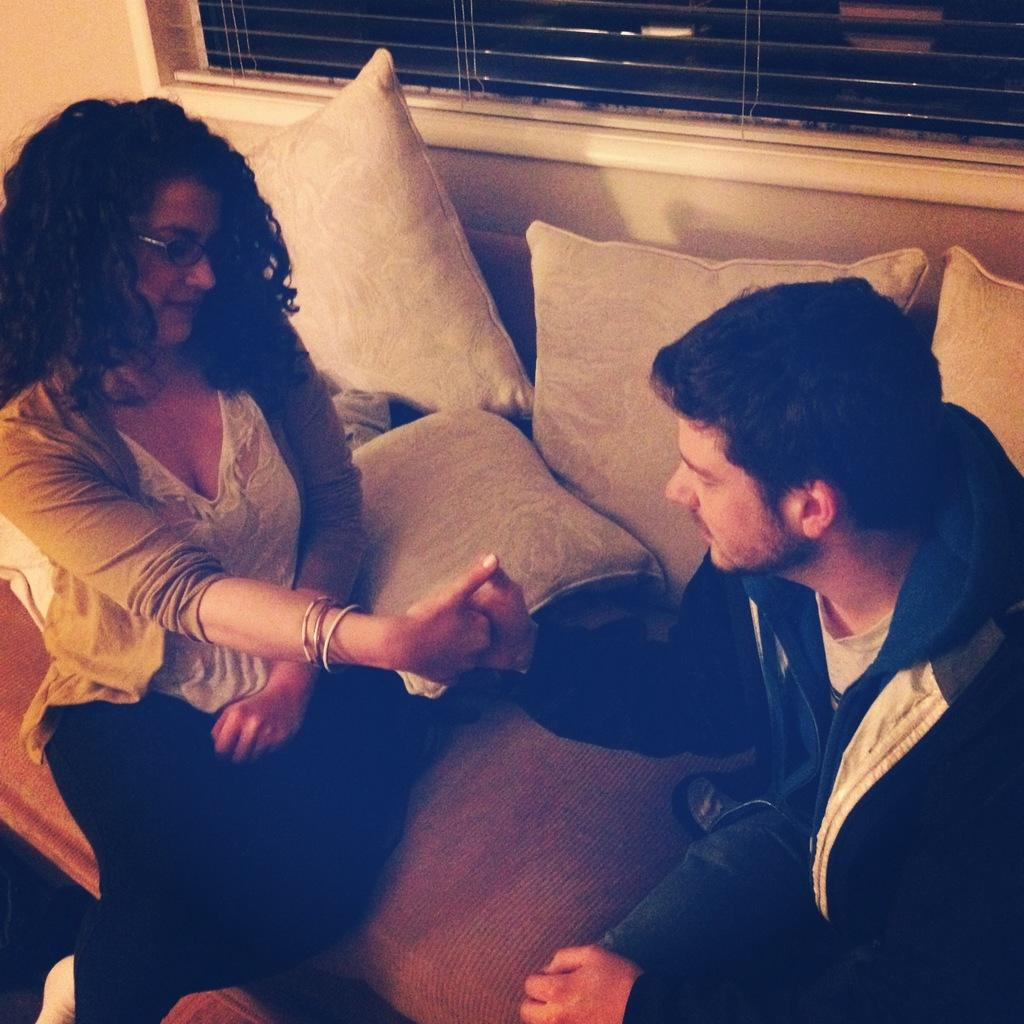Who is present in the image? There is a man and a woman in the image. What are the man and woman doing in the image? The man and woman are sitting on a sofa and shaking hands. What is in front of the sofa? There are pillows in front of the sofa. What can be seen in the background of the image? There is a window visible in the background. What type of shoe is the man wearing in the image? There is no shoe visible in the image, as the man and woman are sitting on a sofa. 